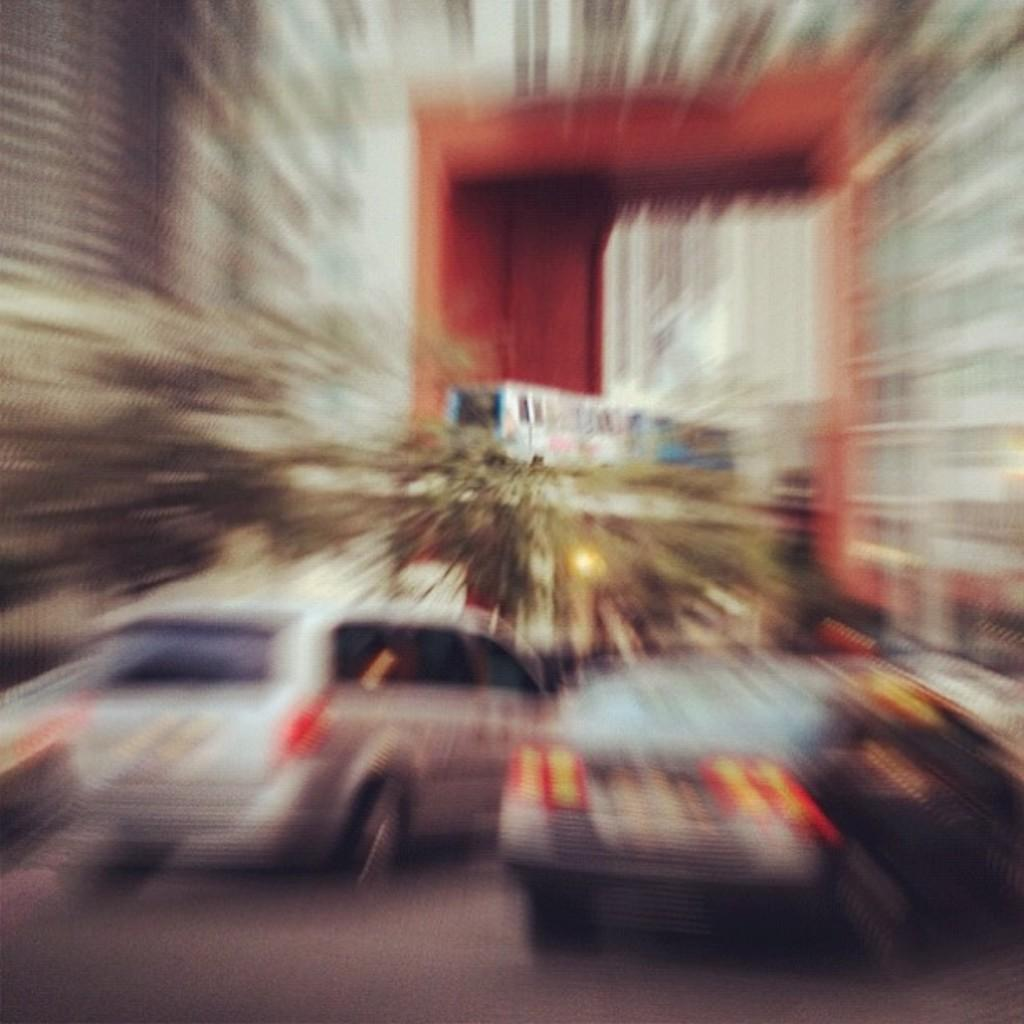What type of structures can be seen in the image? There are buildings in the image. What is moving on the road in the image? Motor vehicles are present on the road. What type of vegetation is visible in the image? Creepers are visible in the image. What mode of transportation can be seen on the track in the image? There is a train on the track in the image. What type of clocks are hanging from the creepers in the image? There are no clocks visible in the image; only creepers are mentioned. What kind of fruit is being used to decorate the train in the image? There is no fruit present in the image; it features a train on the track. 